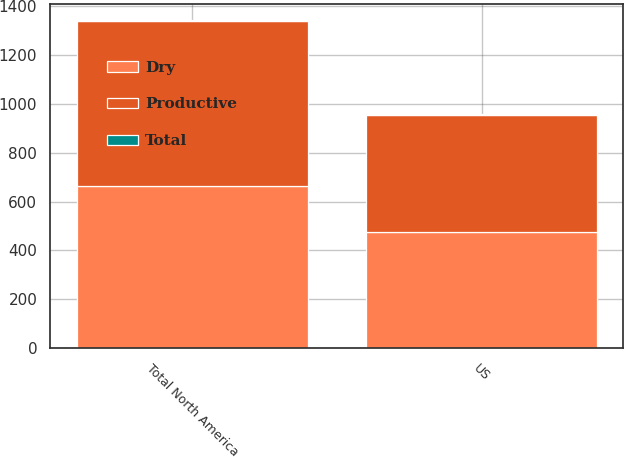Convert chart to OTSL. <chart><loc_0><loc_0><loc_500><loc_500><stacked_bar_chart><ecel><fcel>US<fcel>Total North America<nl><fcel>Dry<fcel>474.4<fcel>665.2<nl><fcel>Total<fcel>0.4<fcel>1.4<nl><fcel>Productive<fcel>481<fcel>673.3<nl></chart> 